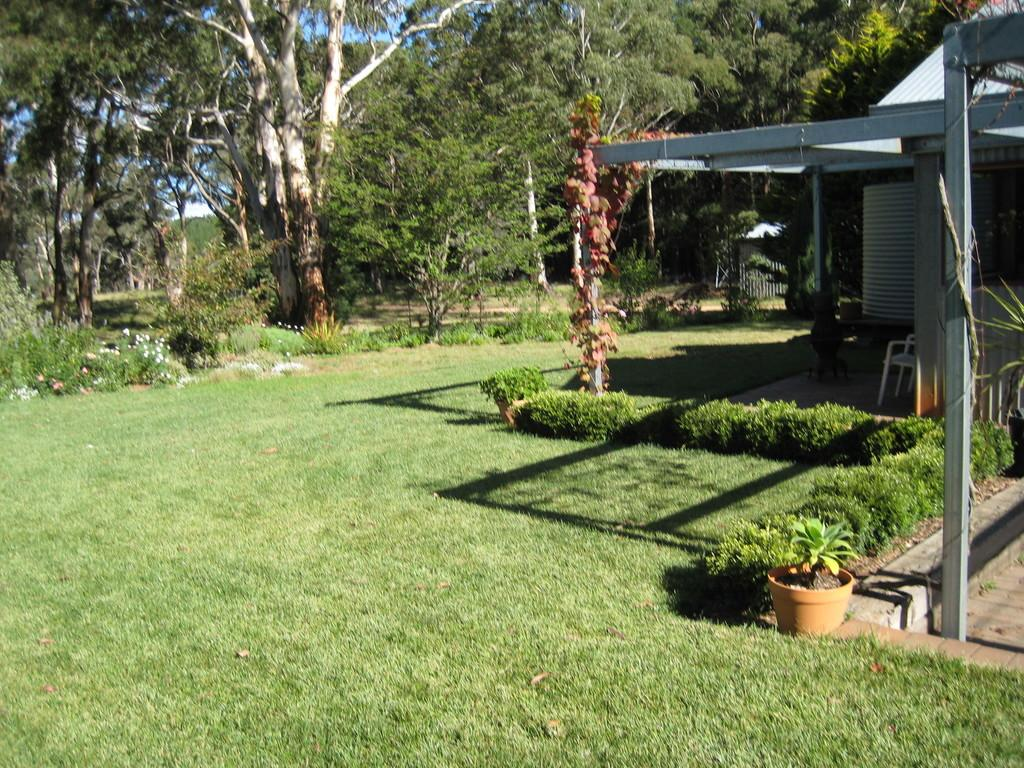What type of vegetation can be seen in the image? There are trees, grass, and plants in the image. What type of structure is present in the image? There is a building in the image. What type of entrance is visible in the image? There is a gate in the image. What type of seating is present in the image? There are chairs in the image. What type of flora can be seen in the image? There are flowers in the image. What part of the natural environment is visible in the image? The sky is visible in the background of the image. What type of box is used to store the belief in the image? There is no box or belief present in the image. What type of camp can be seen in the image? There is no camp present in the image. 